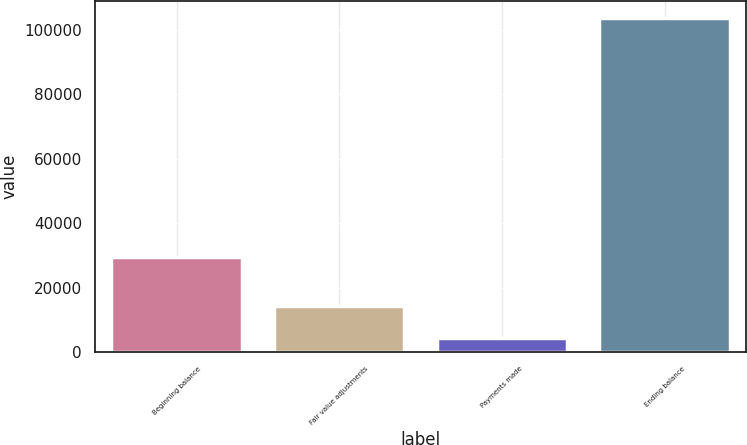Convert chart. <chart><loc_0><loc_0><loc_500><loc_500><bar_chart><fcel>Beginning balance<fcel>Fair value adjustments<fcel>Payments made<fcel>Ending balance<nl><fcel>29500<fcel>14243.6<fcel>4294<fcel>103790<nl></chart> 